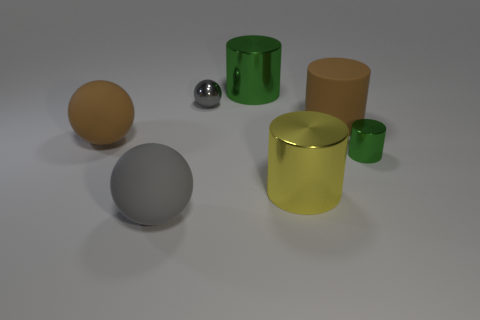What number of big objects are the same color as the rubber cylinder?
Give a very brief answer. 1. What is the size of the matte object that is the same shape as the big green metal object?
Provide a short and direct response. Large. There is a brown thing right of the small gray metal object; is its shape the same as the tiny green metallic thing?
Keep it short and to the point. Yes. The green object that is in front of the small object that is behind the tiny green metallic cylinder is what shape?
Offer a terse response. Cylinder. What color is the matte thing that is the same shape as the tiny green metal object?
Your response must be concise. Brown. There is a tiny metal cylinder; is it the same color as the large object that is behind the small gray sphere?
Your response must be concise. Yes. There is a metal thing that is to the left of the tiny metal cylinder and in front of the small gray thing; what is its shape?
Your response must be concise. Cylinder. Is the number of small green things less than the number of purple objects?
Offer a terse response. No. Are there any big cyan shiny objects?
Offer a terse response. No. How many other objects are there of the same size as the rubber cylinder?
Provide a succinct answer. 4. 